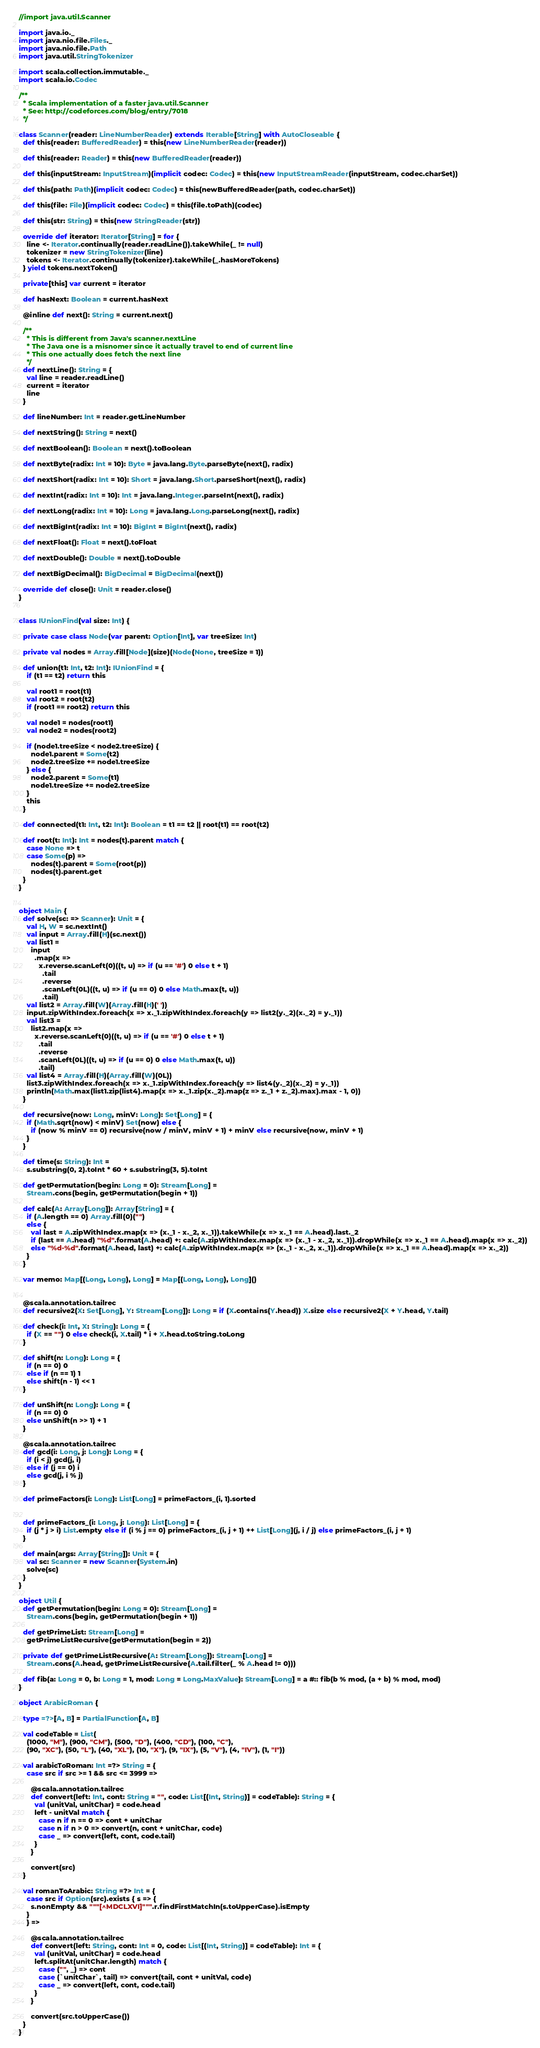<code> <loc_0><loc_0><loc_500><loc_500><_Scala_>//import java.util.Scanner

import java.io._
import java.nio.file.Files._
import java.nio.file.Path
import java.util.StringTokenizer

import scala.collection.immutable._
import scala.io.Codec

/**
  * Scala implementation of a faster java.util.Scanner
  * See: http://codeforces.com/blog/entry/7018
  */

class Scanner(reader: LineNumberReader) extends Iterable[String] with AutoCloseable {
  def this(reader: BufferedReader) = this(new LineNumberReader(reader))

  def this(reader: Reader) = this(new BufferedReader(reader))

  def this(inputStream: InputStream)(implicit codec: Codec) = this(new InputStreamReader(inputStream, codec.charSet))

  def this(path: Path)(implicit codec: Codec) = this(newBufferedReader(path, codec.charSet))

  def this(file: File)(implicit codec: Codec) = this(file.toPath)(codec)

  def this(str: String) = this(new StringReader(str))

  override def iterator: Iterator[String] = for {
    line <- Iterator.continually(reader.readLine()).takeWhile(_ != null)
    tokenizer = new StringTokenizer(line)
    tokens <- Iterator.continually(tokenizer).takeWhile(_.hasMoreTokens)
  } yield tokens.nextToken()

  private[this] var current = iterator

  def hasNext: Boolean = current.hasNext

  @inline def next(): String = current.next()

  /**
    * This is different from Java's scanner.nextLine
    * The Java one is a misnomer since it actually travel to end of current line
    * This one actually does fetch the next line
    */
  def nextLine(): String = {
    val line = reader.readLine()
    current = iterator
    line
  }

  def lineNumber: Int = reader.getLineNumber

  def nextString(): String = next()

  def nextBoolean(): Boolean = next().toBoolean

  def nextByte(radix: Int = 10): Byte = java.lang.Byte.parseByte(next(), radix)

  def nextShort(radix: Int = 10): Short = java.lang.Short.parseShort(next(), radix)

  def nextInt(radix: Int = 10): Int = java.lang.Integer.parseInt(next(), radix)

  def nextLong(radix: Int = 10): Long = java.lang.Long.parseLong(next(), radix)

  def nextBigInt(radix: Int = 10): BigInt = BigInt(next(), radix)

  def nextFloat(): Float = next().toFloat

  def nextDouble(): Double = next().toDouble

  def nextBigDecimal(): BigDecimal = BigDecimal(next())

  override def close(): Unit = reader.close()
}


class IUnionFind(val size: Int) {

  private case class Node(var parent: Option[Int], var treeSize: Int)

  private val nodes = Array.fill[Node](size)(Node(None, treeSize = 1))

  def union(t1: Int, t2: Int): IUnionFind = {
    if (t1 == t2) return this

    val root1 = root(t1)
    val root2 = root(t2)
    if (root1 == root2) return this

    val node1 = nodes(root1)
    val node2 = nodes(root2)

    if (node1.treeSize < node2.treeSize) {
      node1.parent = Some(t2)
      node2.treeSize += node1.treeSize
    } else {
      node2.parent = Some(t1)
      node1.treeSize += node2.treeSize
    }
    this
  }

  def connected(t1: Int, t2: Int): Boolean = t1 == t2 || root(t1) == root(t2)

  def root(t: Int): Int = nodes(t).parent match {
    case None => t
    case Some(p) =>
      nodes(t).parent = Some(root(p))
      nodes(t).parent.get
  }
}


object Main {
  def solve(sc: => Scanner): Unit = {
    val H, W = sc.nextInt()
    val input = Array.fill(H)(sc.next())
    val list1 =
      input
        .map(x =>
          x.reverse.scanLeft(0)((t, u) => if (u == '#') 0 else t + 1)
            .tail
            .reverse
            .scanLeft(0L)((t, u) => if (u == 0) 0 else Math.max(t, u))
            .tail)
    val list2 = Array.fill(W)(Array.fill(H)(' '))
    input.zipWithIndex.foreach(x => x._1.zipWithIndex.foreach(y => list2(y._2)(x._2) = y._1))
    val list3 =
      list2.map(x =>
        x.reverse.scanLeft(0)((t, u) => if (u == '#') 0 else t + 1)
          .tail
          .reverse
          .scanLeft(0L)((t, u) => if (u == 0) 0 else Math.max(t, u))
          .tail)
    val list4 = Array.fill(H)(Array.fill(W)(0L))
    list3.zipWithIndex.foreach(x => x._1.zipWithIndex.foreach(y => list4(y._2)(x._2) = y._1))
    println(Math.max(list1.zip(list4).map(x => x._1.zip(x._2).map(z => z._1 + z._2).max).max - 1, 0))
  }

  def recursive(now: Long, minV: Long): Set[Long] = {
    if (Math.sqrt(now) < minV) Set(now) else {
      if (now % minV == 0) recursive(now / minV, minV + 1) + minV else recursive(now, minV + 1)
    }
  }

  def time(s: String): Int =
    s.substring(0, 2).toInt * 60 + s.substring(3, 5).toInt

  def getPermutation(begin: Long = 0): Stream[Long] =
    Stream.cons(begin, getPermutation(begin + 1))

  def calc(A: Array[Long]): Array[String] = {
    if (A.length == 0) Array.fill(0)("")
    else {
      val last = A.zipWithIndex.map(x => (x._1 - x._2, x._1)).takeWhile(x => x._1 == A.head).last._2
      if (last == A.head) "%d".format(A.head) +: calc(A.zipWithIndex.map(x => (x._1 - x._2, x._1)).dropWhile(x => x._1 == A.head).map(x => x._2))
      else "%d-%d".format(A.head, last) +: calc(A.zipWithIndex.map(x => (x._1 - x._2, x._1)).dropWhile(x => x._1 == A.head).map(x => x._2))
    }
  }

  var memo: Map[(Long, Long), Long] = Map[(Long, Long), Long]()


  @scala.annotation.tailrec
  def recursive2(X: Set[Long], Y: Stream[Long]): Long = if (X.contains(Y.head)) X.size else recursive2(X + Y.head, Y.tail)

  def check(i: Int, X: String): Long = {
    if (X == "") 0 else check(i, X.tail) * i + X.head.toString.toLong
  }

  def shift(n: Long): Long = {
    if (n == 0) 0
    else if (n == 1) 1
    else shift(n - 1) << 1
  }

  def unShift(n: Long): Long = {
    if (n == 0) 0
    else unShift(n >> 1) + 1
  }

  @scala.annotation.tailrec
  def gcd(i: Long, j: Long): Long = {
    if (i < j) gcd(j, i)
    else if (j == 0) i
    else gcd(j, i % j)
  }

  def primeFactors(i: Long): List[Long] = primeFactors_(i, 1).sorted


  def primeFactors_(i: Long, j: Long): List[Long] = {
    if (j * j > i) List.empty else if (i % j == 0) primeFactors_(i, j + 1) ++ List[Long](j, i / j) else primeFactors_(i, j + 1)
  }

  def main(args: Array[String]): Unit = {
    val sc: Scanner = new Scanner(System.in)
    solve(sc)
  }
}

object Util {
  def getPermutation(begin: Long = 0): Stream[Long] =
    Stream.cons(begin, getPermutation(begin + 1))

  def getPrimeList: Stream[Long] =
    getPrimeListRecursive(getPermutation(begin = 2))

  private def getPrimeListRecursive(A: Stream[Long]): Stream[Long] =
    Stream.cons(A.head, getPrimeListRecursive(A.tail.filter(_ % A.head != 0)))

  def fib(a: Long = 0, b: Long = 1, mod: Long = Long.MaxValue): Stream[Long] = a #:: fib(b % mod, (a + b) % mod, mod)
}

object ArabicRoman {

  type =?>[A, B] = PartialFunction[A, B]

  val codeTable = List(
    (1000, "M"), (900, "CM"), (500, "D"), (400, "CD"), (100, "C"),
    (90, "XC"), (50, "L"), (40, "XL"), (10, "X"), (9, "IX"), (5, "V"), (4, "IV"), (1, "I"))

  val arabicToRoman: Int =?> String = {
    case src if src >= 1 && src <= 3999 =>

      @scala.annotation.tailrec
      def convert(left: Int, cont: String = "", code: List[(Int, String)] = codeTable): String = {
        val (unitVal, unitChar) = code.head
        left - unitVal match {
          case n if n == 0 => cont + unitChar
          case n if n > 0 => convert(n, cont + unitChar, code)
          case _ => convert(left, cont, code.tail)
        }
      }

      convert(src)
  }

  val romanToArabic: String =?> Int = {
    case src if Option(src).exists { s => {
      s.nonEmpty && """[^MDCLXVI]""".r.findFirstMatchIn(s.toUpperCase).isEmpty
    }
    } =>

      @scala.annotation.tailrec
      def convert(left: String, cont: Int = 0, code: List[(Int, String)] = codeTable): Int = {
        val (unitVal, unitChar) = code.head
        left.splitAt(unitChar.length) match {
          case ("", _) => cont
          case (`unitChar`, tail) => convert(tail, cont + unitVal, code)
          case _ => convert(left, cont, code.tail)
        }
      }

      convert(src.toUpperCase())
  }
}
</code> 